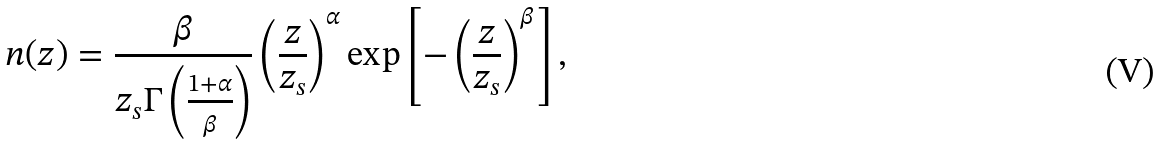Convert formula to latex. <formula><loc_0><loc_0><loc_500><loc_500>n ( z ) = \frac { \beta } { z _ { s } \Gamma \left ( \frac { 1 + \alpha } { \beta } \right ) } \left ( \frac { z } { z _ { s } } \right ) ^ { \alpha } \exp \left [ - \left ( \frac { z } { z _ { s } } \right ) ^ { \beta } \right ] ,</formula> 